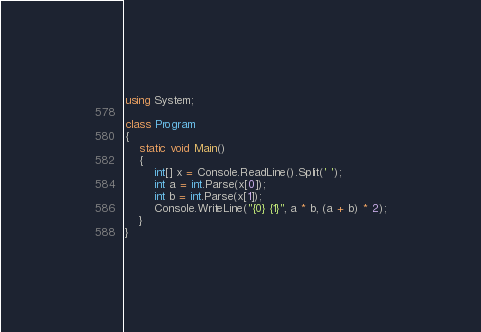<code> <loc_0><loc_0><loc_500><loc_500><_C#_>using System;

class Program
{
    static void Main()
    {
        int[] x = Console.ReadLine().Split(' ');
        int a = int.Parse(x[0]);
        int b = int.Parse(x[1]);
        Console.WriteLine("{0} {1}", a * b, (a + b) * 2);
    }
}
</code> 